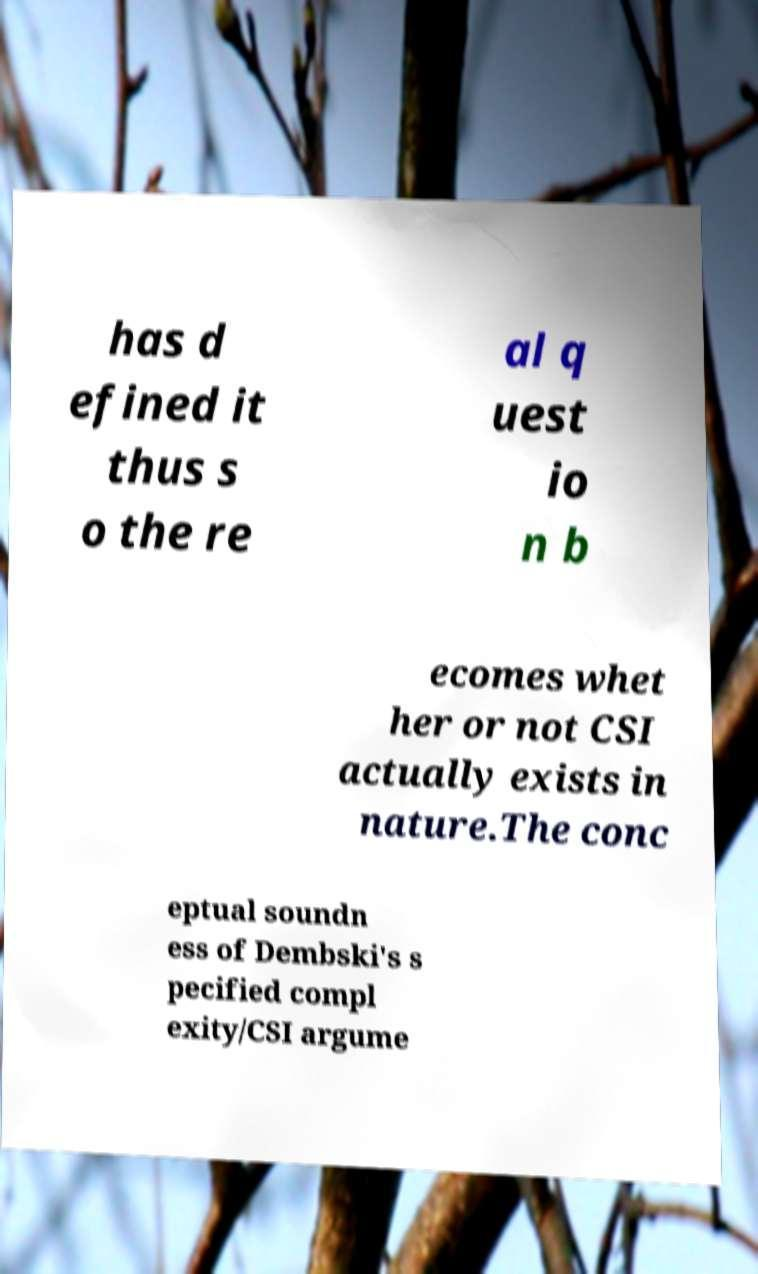Could you extract and type out the text from this image? has d efined it thus s o the re al q uest io n b ecomes whet her or not CSI actually exists in nature.The conc eptual soundn ess of Dembski's s pecified compl exity/CSI argume 